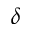Convert formula to latex. <formula><loc_0><loc_0><loc_500><loc_500>\delta</formula> 